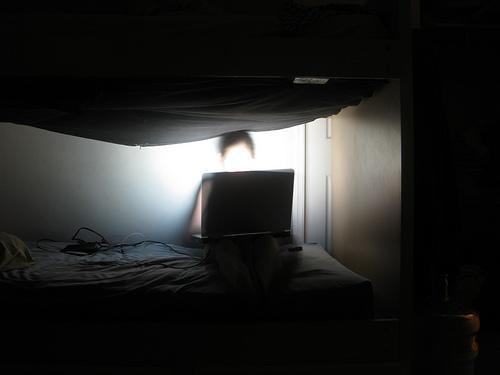How many people are in the photo?
Give a very brief answer. 1. 